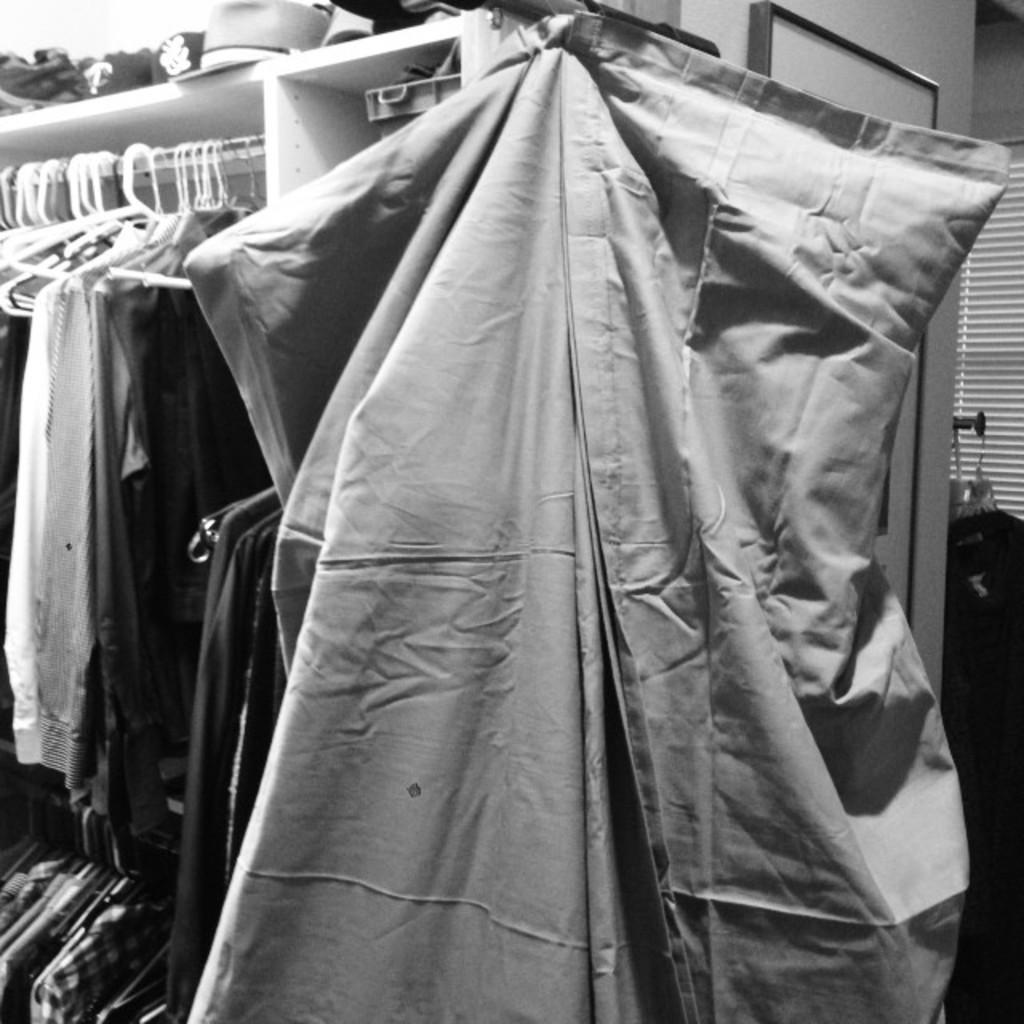How would you summarize this image in a sentence or two? This is black and white image in this image there are clothes. 